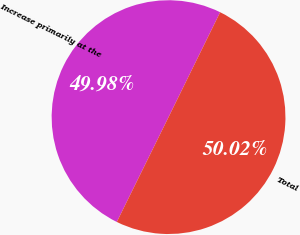Convert chart to OTSL. <chart><loc_0><loc_0><loc_500><loc_500><pie_chart><fcel>Increase primarily at the<fcel>Total<nl><fcel>49.98%<fcel>50.02%<nl></chart> 